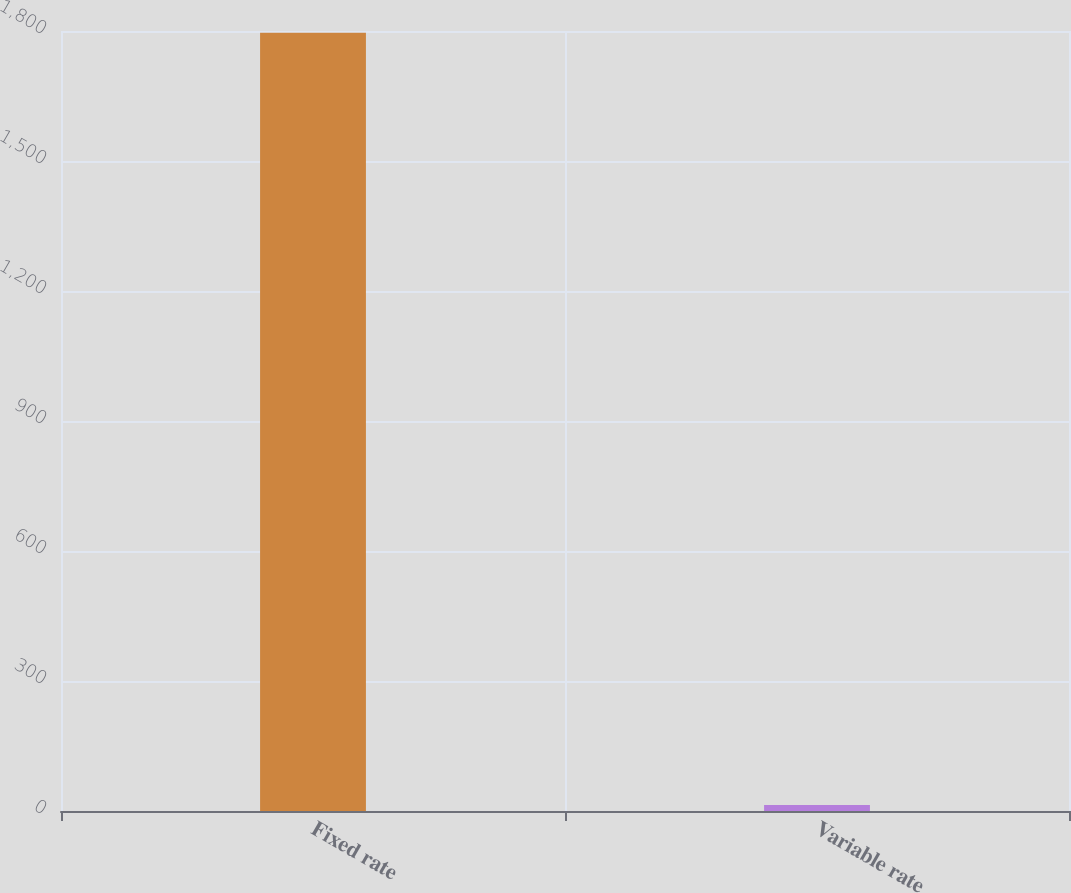Convert chart. <chart><loc_0><loc_0><loc_500><loc_500><bar_chart><fcel>Fixed rate<fcel>Variable rate<nl><fcel>1796<fcel>14<nl></chart> 